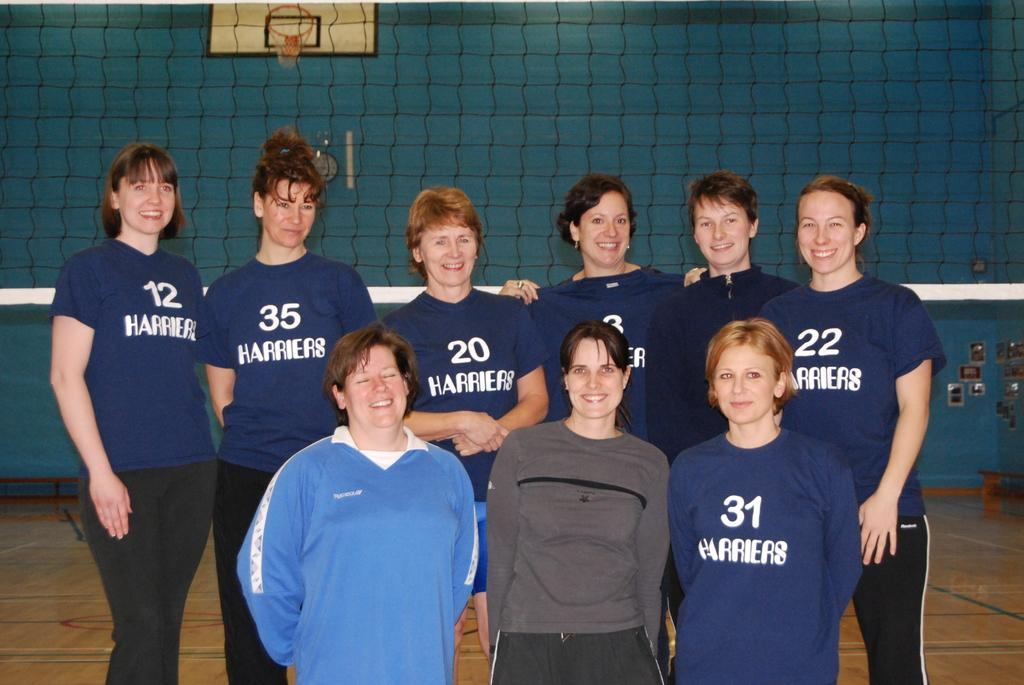<image>
Share a concise interpretation of the image provided. A group of women stand in front of a net wearing blue shirts that say Harriers. 